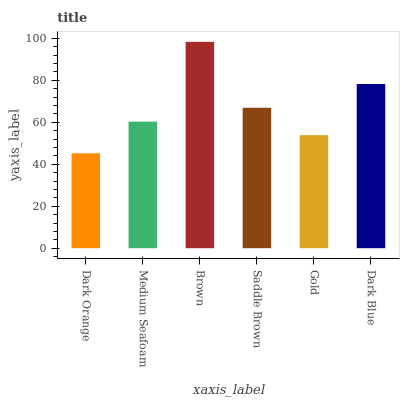Is Dark Orange the minimum?
Answer yes or no. Yes. Is Brown the maximum?
Answer yes or no. Yes. Is Medium Seafoam the minimum?
Answer yes or no. No. Is Medium Seafoam the maximum?
Answer yes or no. No. Is Medium Seafoam greater than Dark Orange?
Answer yes or no. Yes. Is Dark Orange less than Medium Seafoam?
Answer yes or no. Yes. Is Dark Orange greater than Medium Seafoam?
Answer yes or no. No. Is Medium Seafoam less than Dark Orange?
Answer yes or no. No. Is Saddle Brown the high median?
Answer yes or no. Yes. Is Medium Seafoam the low median?
Answer yes or no. Yes. Is Dark Orange the high median?
Answer yes or no. No. Is Dark Orange the low median?
Answer yes or no. No. 